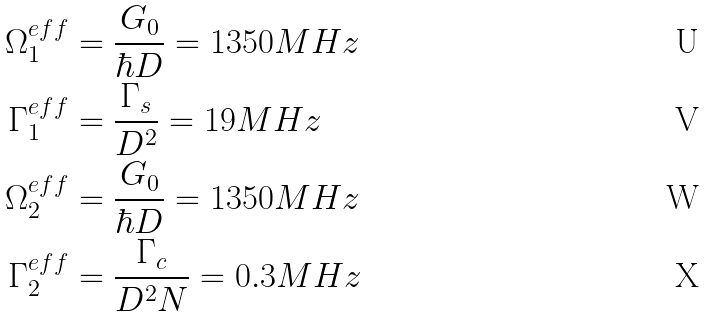Convert formula to latex. <formula><loc_0><loc_0><loc_500><loc_500>\Omega _ { 1 } ^ { e f f } & = \frac { G _ { 0 } } { \hbar { D } } = 1 3 5 0 M H z \\ \Gamma _ { 1 } ^ { e f f } & = \frac { \Gamma _ { s } } { D ^ { 2 } } = 1 9 M H z \\ \Omega _ { 2 } ^ { e f f } & = \frac { G _ { 0 } } { \hbar { D } } = 1 3 5 0 M H z \\ \Gamma _ { 2 } ^ { e f f } & = \frac { \Gamma _ { c } } { D ^ { 2 } N } = 0 . 3 M H z</formula> 